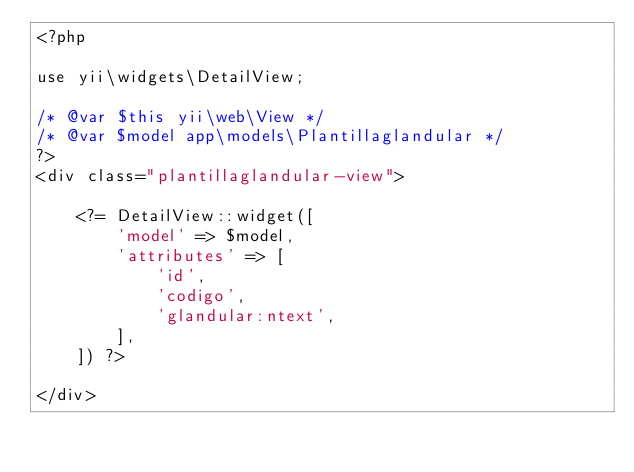Convert code to text. <code><loc_0><loc_0><loc_500><loc_500><_PHP_><?php

use yii\widgets\DetailView;

/* @var $this yii\web\View */
/* @var $model app\models\Plantillaglandular */
?>
<div class="plantillaglandular-view">

    <?= DetailView::widget([
        'model' => $model,
        'attributes' => [
            'id',
            'codigo',
            'glandular:ntext',
        ],
    ]) ?>

</div>
</code> 